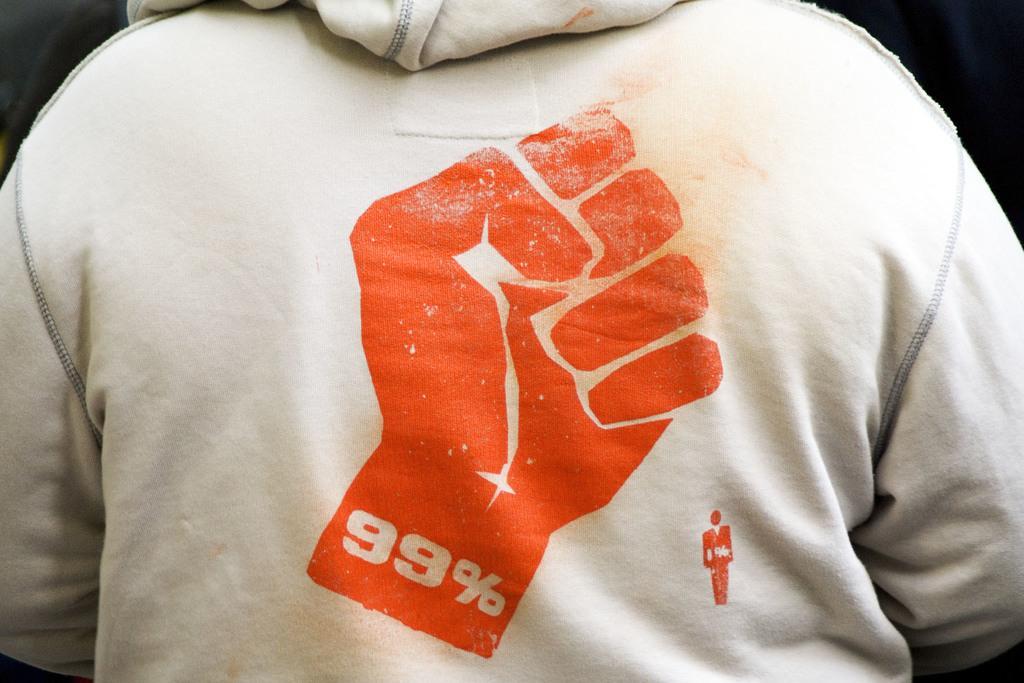In one or two sentences, can you explain what this image depicts? In this image in the foreground there is one person who is wearing a jacket, on the jacket there is one logo and there is a black background. 